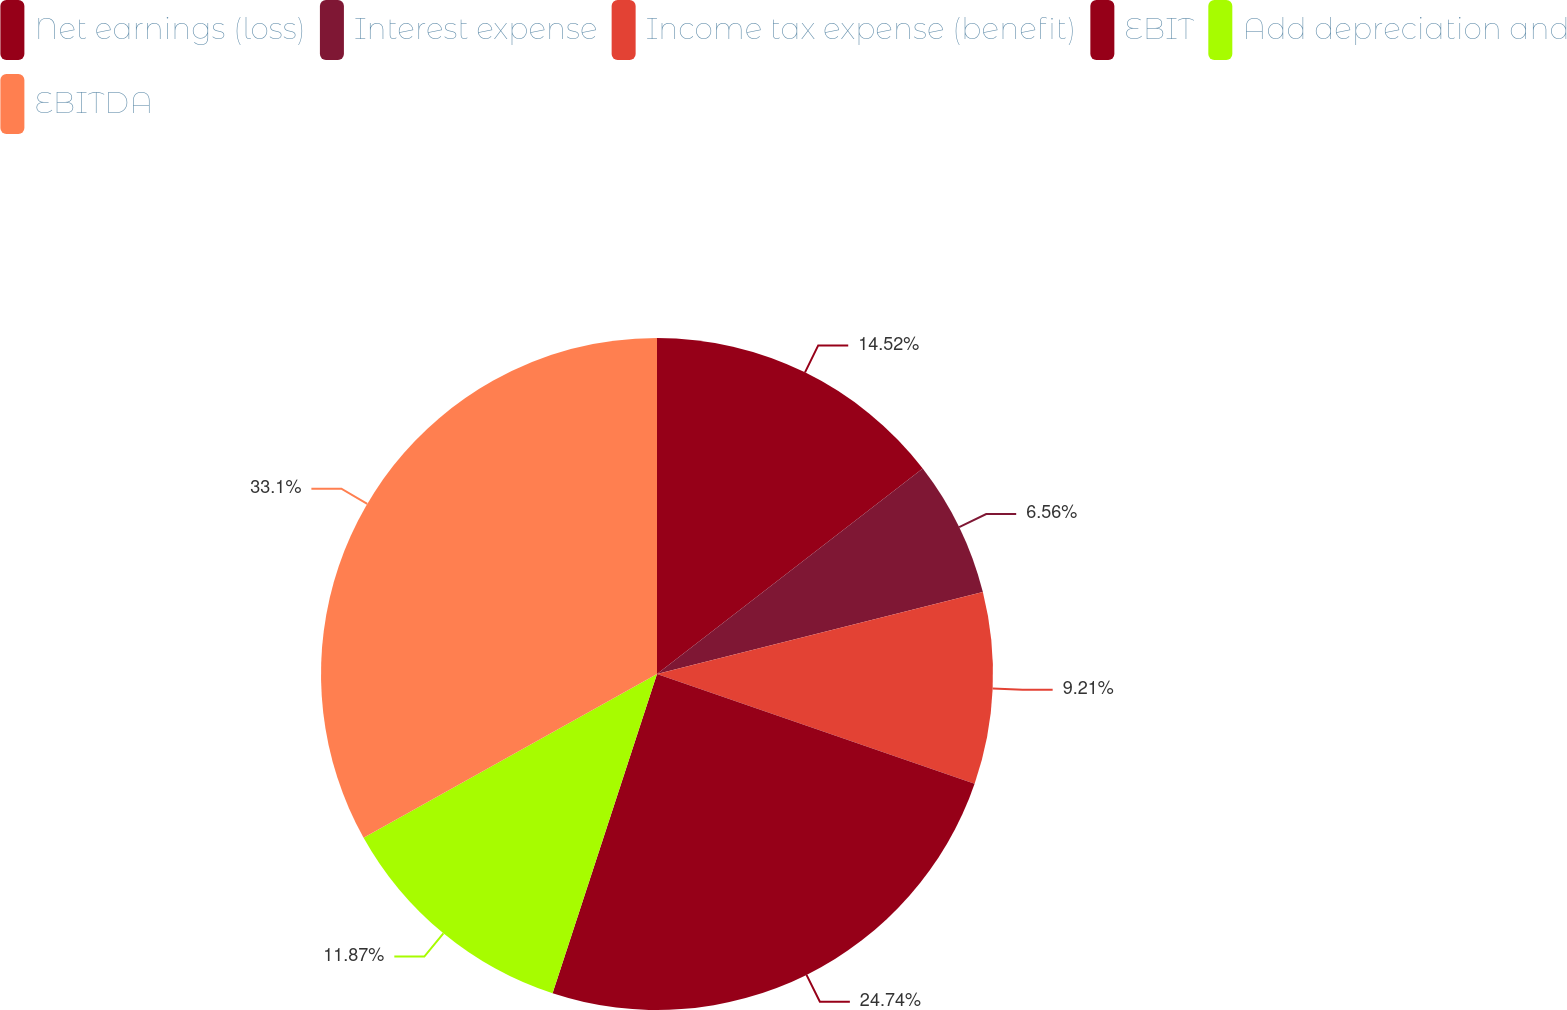Convert chart. <chart><loc_0><loc_0><loc_500><loc_500><pie_chart><fcel>Net earnings (loss)<fcel>Interest expense<fcel>Income tax expense (benefit)<fcel>EBIT<fcel>Add depreciation and<fcel>EBITDA<nl><fcel>14.52%<fcel>6.56%<fcel>9.21%<fcel>24.74%<fcel>11.87%<fcel>33.1%<nl></chart> 